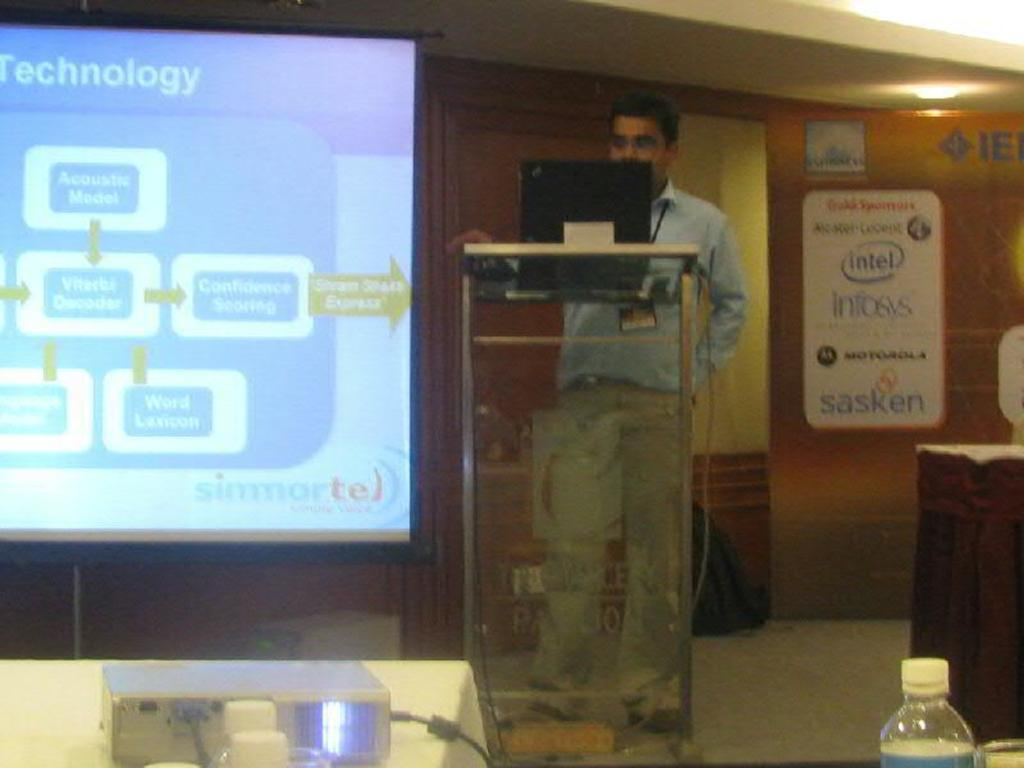<image>
Describe the image concisely. A man standing in the front of the room giving a presentation on technology 